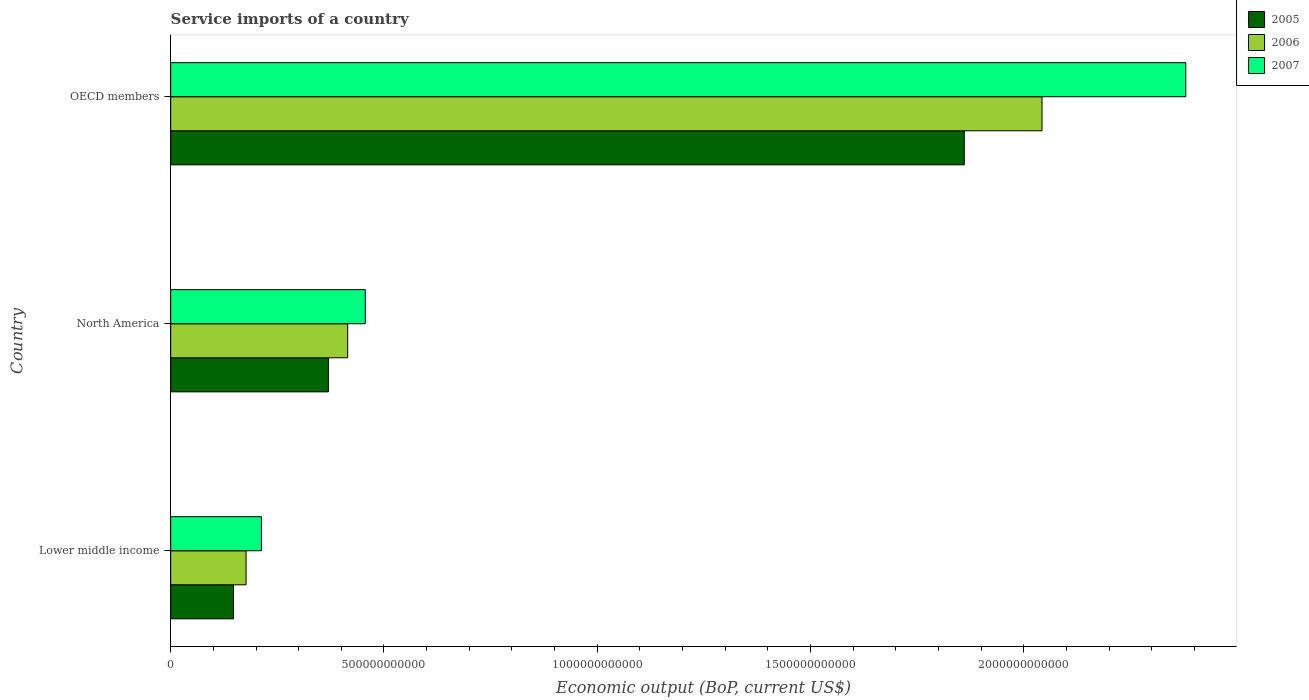How many groups of bars are there?
Keep it short and to the point. 3. How many bars are there on the 3rd tick from the top?
Provide a succinct answer. 3. How many bars are there on the 2nd tick from the bottom?
Give a very brief answer. 3. What is the label of the 2nd group of bars from the top?
Offer a terse response. North America. In how many cases, is the number of bars for a given country not equal to the number of legend labels?
Keep it short and to the point. 0. What is the service imports in 2005 in Lower middle income?
Keep it short and to the point. 1.47e+11. Across all countries, what is the maximum service imports in 2006?
Provide a succinct answer. 2.04e+12. Across all countries, what is the minimum service imports in 2007?
Give a very brief answer. 2.13e+11. In which country was the service imports in 2005 minimum?
Make the answer very short. Lower middle income. What is the total service imports in 2006 in the graph?
Your answer should be very brief. 2.63e+12. What is the difference between the service imports in 2005 in North America and that in OECD members?
Make the answer very short. -1.49e+12. What is the difference between the service imports in 2005 in North America and the service imports in 2006 in OECD members?
Make the answer very short. -1.67e+12. What is the average service imports in 2007 per country?
Provide a succinct answer. 1.02e+12. What is the difference between the service imports in 2006 and service imports in 2007 in OECD members?
Provide a short and direct response. -3.37e+11. In how many countries, is the service imports in 2006 greater than 1000000000000 US$?
Your answer should be compact. 1. What is the ratio of the service imports in 2007 in Lower middle income to that in North America?
Your answer should be very brief. 0.47. Is the service imports in 2006 in North America less than that in OECD members?
Make the answer very short. Yes. Is the difference between the service imports in 2006 in North America and OECD members greater than the difference between the service imports in 2007 in North America and OECD members?
Your answer should be compact. Yes. What is the difference between the highest and the second highest service imports in 2006?
Your answer should be compact. 1.63e+12. What is the difference between the highest and the lowest service imports in 2007?
Provide a succinct answer. 2.17e+12. What does the 2nd bar from the top in North America represents?
Offer a very short reply. 2006. What does the 3rd bar from the bottom in OECD members represents?
Provide a short and direct response. 2007. Is it the case that in every country, the sum of the service imports in 2007 and service imports in 2005 is greater than the service imports in 2006?
Give a very brief answer. Yes. What is the difference between two consecutive major ticks on the X-axis?
Offer a terse response. 5.00e+11. Does the graph contain any zero values?
Provide a succinct answer. No. How are the legend labels stacked?
Provide a short and direct response. Vertical. What is the title of the graph?
Your response must be concise. Service imports of a country. What is the label or title of the X-axis?
Make the answer very short. Economic output (BoP, current US$). What is the label or title of the Y-axis?
Your response must be concise. Country. What is the Economic output (BoP, current US$) of 2005 in Lower middle income?
Your answer should be compact. 1.47e+11. What is the Economic output (BoP, current US$) of 2006 in Lower middle income?
Ensure brevity in your answer.  1.77e+11. What is the Economic output (BoP, current US$) in 2007 in Lower middle income?
Your answer should be compact. 2.13e+11. What is the Economic output (BoP, current US$) of 2005 in North America?
Your response must be concise. 3.70e+11. What is the Economic output (BoP, current US$) in 2006 in North America?
Offer a very short reply. 4.15e+11. What is the Economic output (BoP, current US$) in 2007 in North America?
Your answer should be compact. 4.56e+11. What is the Economic output (BoP, current US$) in 2005 in OECD members?
Offer a terse response. 1.86e+12. What is the Economic output (BoP, current US$) in 2006 in OECD members?
Make the answer very short. 2.04e+12. What is the Economic output (BoP, current US$) in 2007 in OECD members?
Offer a terse response. 2.38e+12. Across all countries, what is the maximum Economic output (BoP, current US$) of 2005?
Your response must be concise. 1.86e+12. Across all countries, what is the maximum Economic output (BoP, current US$) of 2006?
Keep it short and to the point. 2.04e+12. Across all countries, what is the maximum Economic output (BoP, current US$) of 2007?
Make the answer very short. 2.38e+12. Across all countries, what is the minimum Economic output (BoP, current US$) of 2005?
Your answer should be very brief. 1.47e+11. Across all countries, what is the minimum Economic output (BoP, current US$) in 2006?
Make the answer very short. 1.77e+11. Across all countries, what is the minimum Economic output (BoP, current US$) of 2007?
Provide a short and direct response. 2.13e+11. What is the total Economic output (BoP, current US$) of 2005 in the graph?
Ensure brevity in your answer.  2.38e+12. What is the total Economic output (BoP, current US$) of 2006 in the graph?
Make the answer very short. 2.63e+12. What is the total Economic output (BoP, current US$) of 2007 in the graph?
Provide a short and direct response. 3.05e+12. What is the difference between the Economic output (BoP, current US$) in 2005 in Lower middle income and that in North America?
Provide a succinct answer. -2.23e+11. What is the difference between the Economic output (BoP, current US$) of 2006 in Lower middle income and that in North America?
Your answer should be compact. -2.38e+11. What is the difference between the Economic output (BoP, current US$) of 2007 in Lower middle income and that in North America?
Make the answer very short. -2.44e+11. What is the difference between the Economic output (BoP, current US$) in 2005 in Lower middle income and that in OECD members?
Provide a succinct answer. -1.71e+12. What is the difference between the Economic output (BoP, current US$) of 2006 in Lower middle income and that in OECD members?
Make the answer very short. -1.87e+12. What is the difference between the Economic output (BoP, current US$) of 2007 in Lower middle income and that in OECD members?
Your answer should be compact. -2.17e+12. What is the difference between the Economic output (BoP, current US$) of 2005 in North America and that in OECD members?
Offer a very short reply. -1.49e+12. What is the difference between the Economic output (BoP, current US$) of 2006 in North America and that in OECD members?
Provide a succinct answer. -1.63e+12. What is the difference between the Economic output (BoP, current US$) of 2007 in North America and that in OECD members?
Your answer should be very brief. -1.92e+12. What is the difference between the Economic output (BoP, current US$) of 2005 in Lower middle income and the Economic output (BoP, current US$) of 2006 in North America?
Keep it short and to the point. -2.68e+11. What is the difference between the Economic output (BoP, current US$) in 2005 in Lower middle income and the Economic output (BoP, current US$) in 2007 in North America?
Give a very brief answer. -3.09e+11. What is the difference between the Economic output (BoP, current US$) of 2006 in Lower middle income and the Economic output (BoP, current US$) of 2007 in North America?
Make the answer very short. -2.80e+11. What is the difference between the Economic output (BoP, current US$) of 2005 in Lower middle income and the Economic output (BoP, current US$) of 2006 in OECD members?
Provide a short and direct response. -1.90e+12. What is the difference between the Economic output (BoP, current US$) in 2005 in Lower middle income and the Economic output (BoP, current US$) in 2007 in OECD members?
Offer a terse response. -2.23e+12. What is the difference between the Economic output (BoP, current US$) of 2006 in Lower middle income and the Economic output (BoP, current US$) of 2007 in OECD members?
Ensure brevity in your answer.  -2.20e+12. What is the difference between the Economic output (BoP, current US$) of 2005 in North America and the Economic output (BoP, current US$) of 2006 in OECD members?
Your answer should be compact. -1.67e+12. What is the difference between the Economic output (BoP, current US$) in 2005 in North America and the Economic output (BoP, current US$) in 2007 in OECD members?
Make the answer very short. -2.01e+12. What is the difference between the Economic output (BoP, current US$) of 2006 in North America and the Economic output (BoP, current US$) of 2007 in OECD members?
Ensure brevity in your answer.  -1.97e+12. What is the average Economic output (BoP, current US$) in 2005 per country?
Your answer should be compact. 7.93e+11. What is the average Economic output (BoP, current US$) of 2006 per country?
Keep it short and to the point. 8.78e+11. What is the average Economic output (BoP, current US$) of 2007 per country?
Your answer should be compact. 1.02e+12. What is the difference between the Economic output (BoP, current US$) of 2005 and Economic output (BoP, current US$) of 2006 in Lower middle income?
Offer a very short reply. -2.95e+1. What is the difference between the Economic output (BoP, current US$) of 2005 and Economic output (BoP, current US$) of 2007 in Lower middle income?
Make the answer very short. -6.55e+1. What is the difference between the Economic output (BoP, current US$) of 2006 and Economic output (BoP, current US$) of 2007 in Lower middle income?
Ensure brevity in your answer.  -3.59e+1. What is the difference between the Economic output (BoP, current US$) of 2005 and Economic output (BoP, current US$) of 2006 in North America?
Make the answer very short. -4.52e+1. What is the difference between the Economic output (BoP, current US$) in 2005 and Economic output (BoP, current US$) in 2007 in North America?
Your answer should be very brief. -8.65e+1. What is the difference between the Economic output (BoP, current US$) in 2006 and Economic output (BoP, current US$) in 2007 in North America?
Offer a very short reply. -4.13e+1. What is the difference between the Economic output (BoP, current US$) in 2005 and Economic output (BoP, current US$) in 2006 in OECD members?
Offer a terse response. -1.82e+11. What is the difference between the Economic output (BoP, current US$) of 2005 and Economic output (BoP, current US$) of 2007 in OECD members?
Your response must be concise. -5.19e+11. What is the difference between the Economic output (BoP, current US$) of 2006 and Economic output (BoP, current US$) of 2007 in OECD members?
Keep it short and to the point. -3.37e+11. What is the ratio of the Economic output (BoP, current US$) of 2005 in Lower middle income to that in North America?
Your response must be concise. 0.4. What is the ratio of the Economic output (BoP, current US$) in 2006 in Lower middle income to that in North America?
Your answer should be compact. 0.43. What is the ratio of the Economic output (BoP, current US$) in 2007 in Lower middle income to that in North America?
Keep it short and to the point. 0.47. What is the ratio of the Economic output (BoP, current US$) in 2005 in Lower middle income to that in OECD members?
Ensure brevity in your answer.  0.08. What is the ratio of the Economic output (BoP, current US$) of 2006 in Lower middle income to that in OECD members?
Offer a terse response. 0.09. What is the ratio of the Economic output (BoP, current US$) in 2007 in Lower middle income to that in OECD members?
Provide a short and direct response. 0.09. What is the ratio of the Economic output (BoP, current US$) in 2005 in North America to that in OECD members?
Give a very brief answer. 0.2. What is the ratio of the Economic output (BoP, current US$) in 2006 in North America to that in OECD members?
Give a very brief answer. 0.2. What is the ratio of the Economic output (BoP, current US$) of 2007 in North America to that in OECD members?
Ensure brevity in your answer.  0.19. What is the difference between the highest and the second highest Economic output (BoP, current US$) in 2005?
Your answer should be compact. 1.49e+12. What is the difference between the highest and the second highest Economic output (BoP, current US$) in 2006?
Your response must be concise. 1.63e+12. What is the difference between the highest and the second highest Economic output (BoP, current US$) of 2007?
Your response must be concise. 1.92e+12. What is the difference between the highest and the lowest Economic output (BoP, current US$) of 2005?
Offer a very short reply. 1.71e+12. What is the difference between the highest and the lowest Economic output (BoP, current US$) of 2006?
Your answer should be compact. 1.87e+12. What is the difference between the highest and the lowest Economic output (BoP, current US$) in 2007?
Your answer should be very brief. 2.17e+12. 